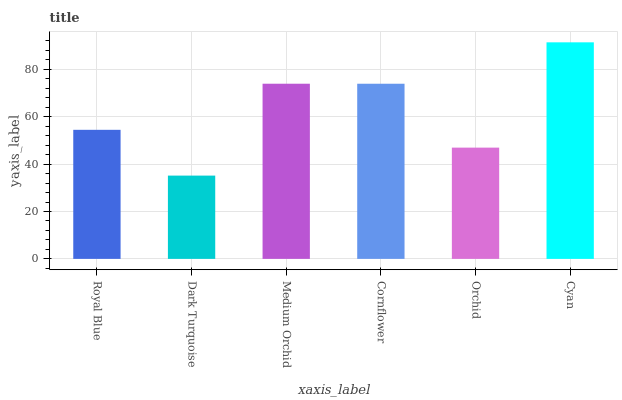Is Dark Turquoise the minimum?
Answer yes or no. Yes. Is Cyan the maximum?
Answer yes or no. Yes. Is Medium Orchid the minimum?
Answer yes or no. No. Is Medium Orchid the maximum?
Answer yes or no. No. Is Medium Orchid greater than Dark Turquoise?
Answer yes or no. Yes. Is Dark Turquoise less than Medium Orchid?
Answer yes or no. Yes. Is Dark Turquoise greater than Medium Orchid?
Answer yes or no. No. Is Medium Orchid less than Dark Turquoise?
Answer yes or no. No. Is Cornflower the high median?
Answer yes or no. Yes. Is Royal Blue the low median?
Answer yes or no. Yes. Is Orchid the high median?
Answer yes or no. No. Is Orchid the low median?
Answer yes or no. No. 